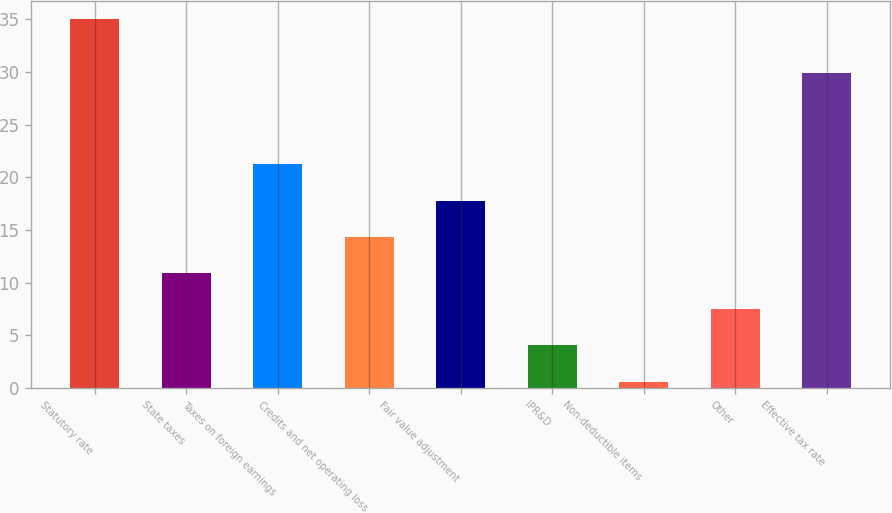<chart> <loc_0><loc_0><loc_500><loc_500><bar_chart><fcel>Statutory rate<fcel>State taxes<fcel>Taxes on foreign earnings<fcel>Credits and net operating loss<fcel>Fair value adjustment<fcel>IPR&D<fcel>Non-deductible items<fcel>Other<fcel>Effective tax rate<nl><fcel>35<fcel>10.92<fcel>21.24<fcel>14.36<fcel>17.8<fcel>4.04<fcel>0.6<fcel>7.48<fcel>29.9<nl></chart> 